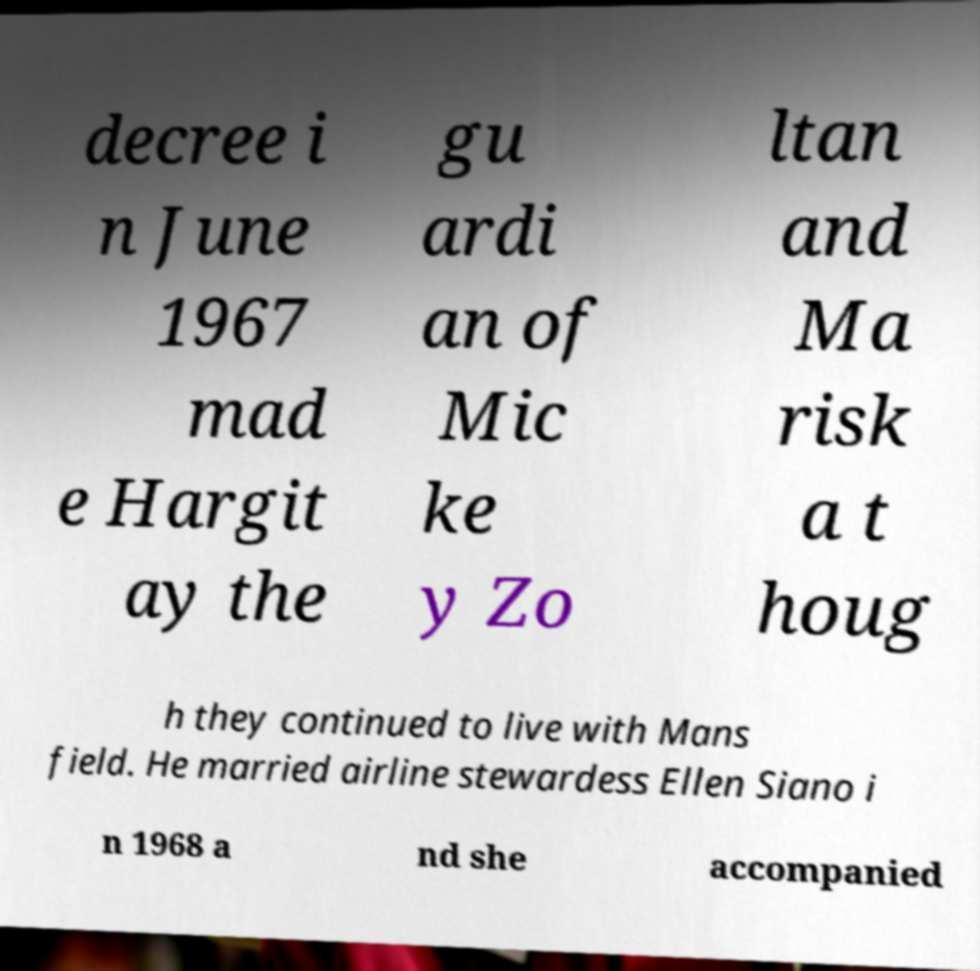Can you read and provide the text displayed in the image?This photo seems to have some interesting text. Can you extract and type it out for me? decree i n June 1967 mad e Hargit ay the gu ardi an of Mic ke y Zo ltan and Ma risk a t houg h they continued to live with Mans field. He married airline stewardess Ellen Siano i n 1968 a nd she accompanied 